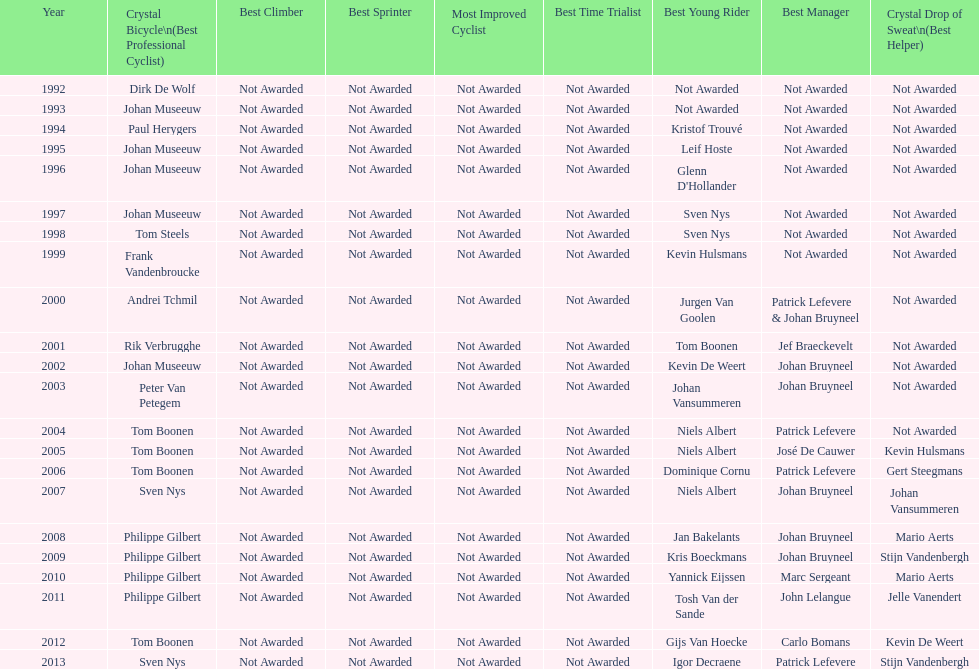Who won the crystal bicycle earlier, boonen or nys? Tom Boonen. 